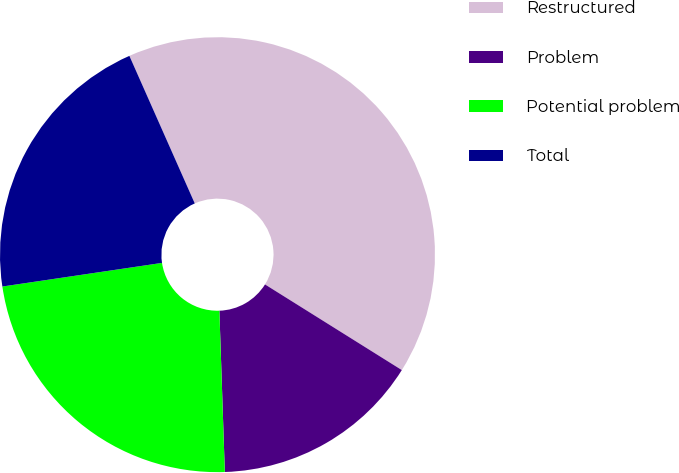Convert chart to OTSL. <chart><loc_0><loc_0><loc_500><loc_500><pie_chart><fcel>Restructured<fcel>Problem<fcel>Potential problem<fcel>Total<nl><fcel>40.54%<fcel>15.56%<fcel>23.2%<fcel>20.7%<nl></chart> 